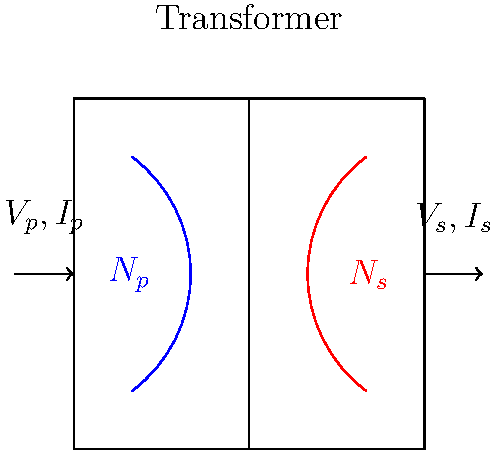As a comic artist, you're working on a sci-fi story involving advanced technology. You need to accurately depict a transformer's efficiency. Given a transformer with $N_p = 500$ primary windings and $N_s = 100$ secondary windings, if the input voltage $V_p = 1000V$ and current $I_p = 10A$, and the output voltage $V_s = 200V$, what is the transformer's efficiency? Let's approach this step-by-step:

1) First, recall the transformer equations:
   $$\frac{V_p}{V_s} = \frac{N_p}{N_s}$$ and $$\frac{I_s}{I_p} = \frac{N_p}{N_s}$$

2) We're given $V_p$, $V_s$, $I_p$, $N_p$, and $N_s$. We need to find $I_s$.

3) Using the current relation:
   $$I_s = I_p \cdot \frac{N_p}{N_s} = 10A \cdot \frac{500}{100} = 50A$$

4) Now we can calculate input and output power:
   $$P_{in} = V_p \cdot I_p = 1000V \cdot 10A = 10,000W$$
   $$P_{out} = V_s \cdot I_s = 200V \cdot 50A = 10,000W$$

5) Efficiency is defined as:
   $$\text{Efficiency} = \frac{P_{out}}{P_{in}} \cdot 100\%$$

6) Plugging in our values:
   $$\text{Efficiency} = \frac{10,000W}{10,000W} \cdot 100\% = 100\%$$
Answer: 100% 